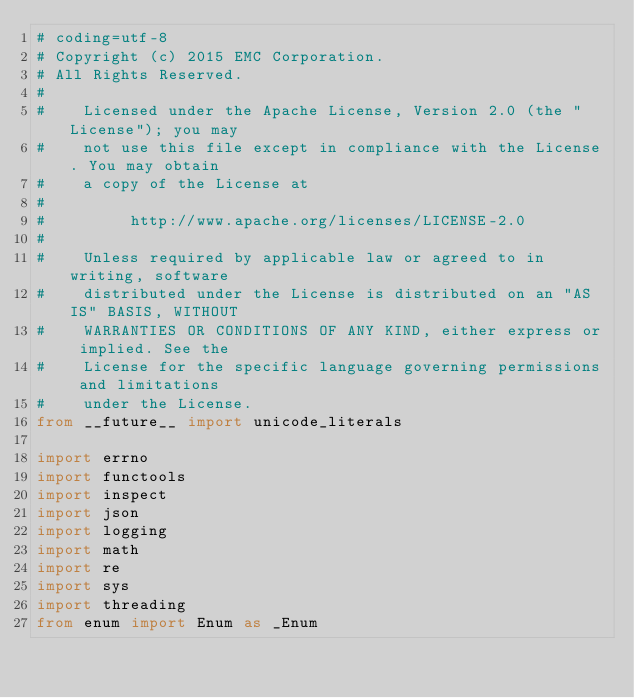Convert code to text. <code><loc_0><loc_0><loc_500><loc_500><_Python_># coding=utf-8
# Copyright (c) 2015 EMC Corporation.
# All Rights Reserved.
#
#    Licensed under the Apache License, Version 2.0 (the "License"); you may
#    not use this file except in compliance with the License. You may obtain
#    a copy of the License at
#
#         http://www.apache.org/licenses/LICENSE-2.0
#
#    Unless required by applicable law or agreed to in writing, software
#    distributed under the License is distributed on an "AS IS" BASIS, WITHOUT
#    WARRANTIES OR CONDITIONS OF ANY KIND, either express or implied. See the
#    License for the specific language governing permissions and limitations
#    under the License.
from __future__ import unicode_literals

import errno
import functools
import inspect
import json
import logging
import math
import re
import sys
import threading
from enum import Enum as _Enum</code> 